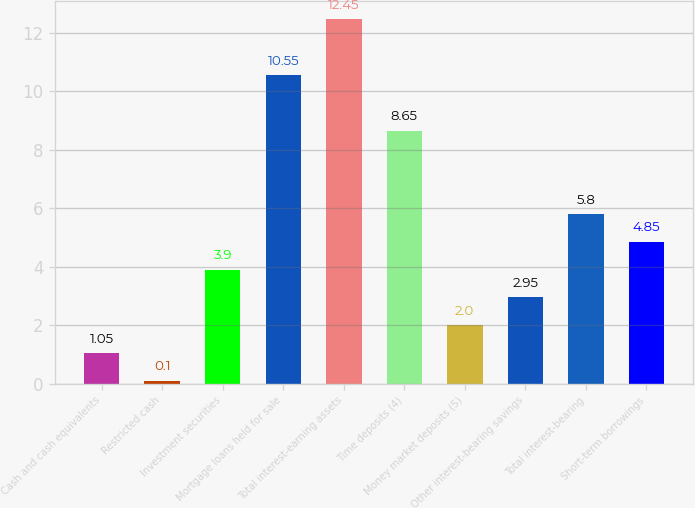Convert chart to OTSL. <chart><loc_0><loc_0><loc_500><loc_500><bar_chart><fcel>Cash and cash equivalents<fcel>Restricted cash<fcel>Investment securities<fcel>Mortgage loans held for sale<fcel>Total interest-earning assets<fcel>Time deposits (4)<fcel>Money market deposits (5)<fcel>Other interest-bearing savings<fcel>Total interest-bearing<fcel>Short-term borrowings<nl><fcel>1.05<fcel>0.1<fcel>3.9<fcel>10.55<fcel>12.45<fcel>8.65<fcel>2<fcel>2.95<fcel>5.8<fcel>4.85<nl></chart> 